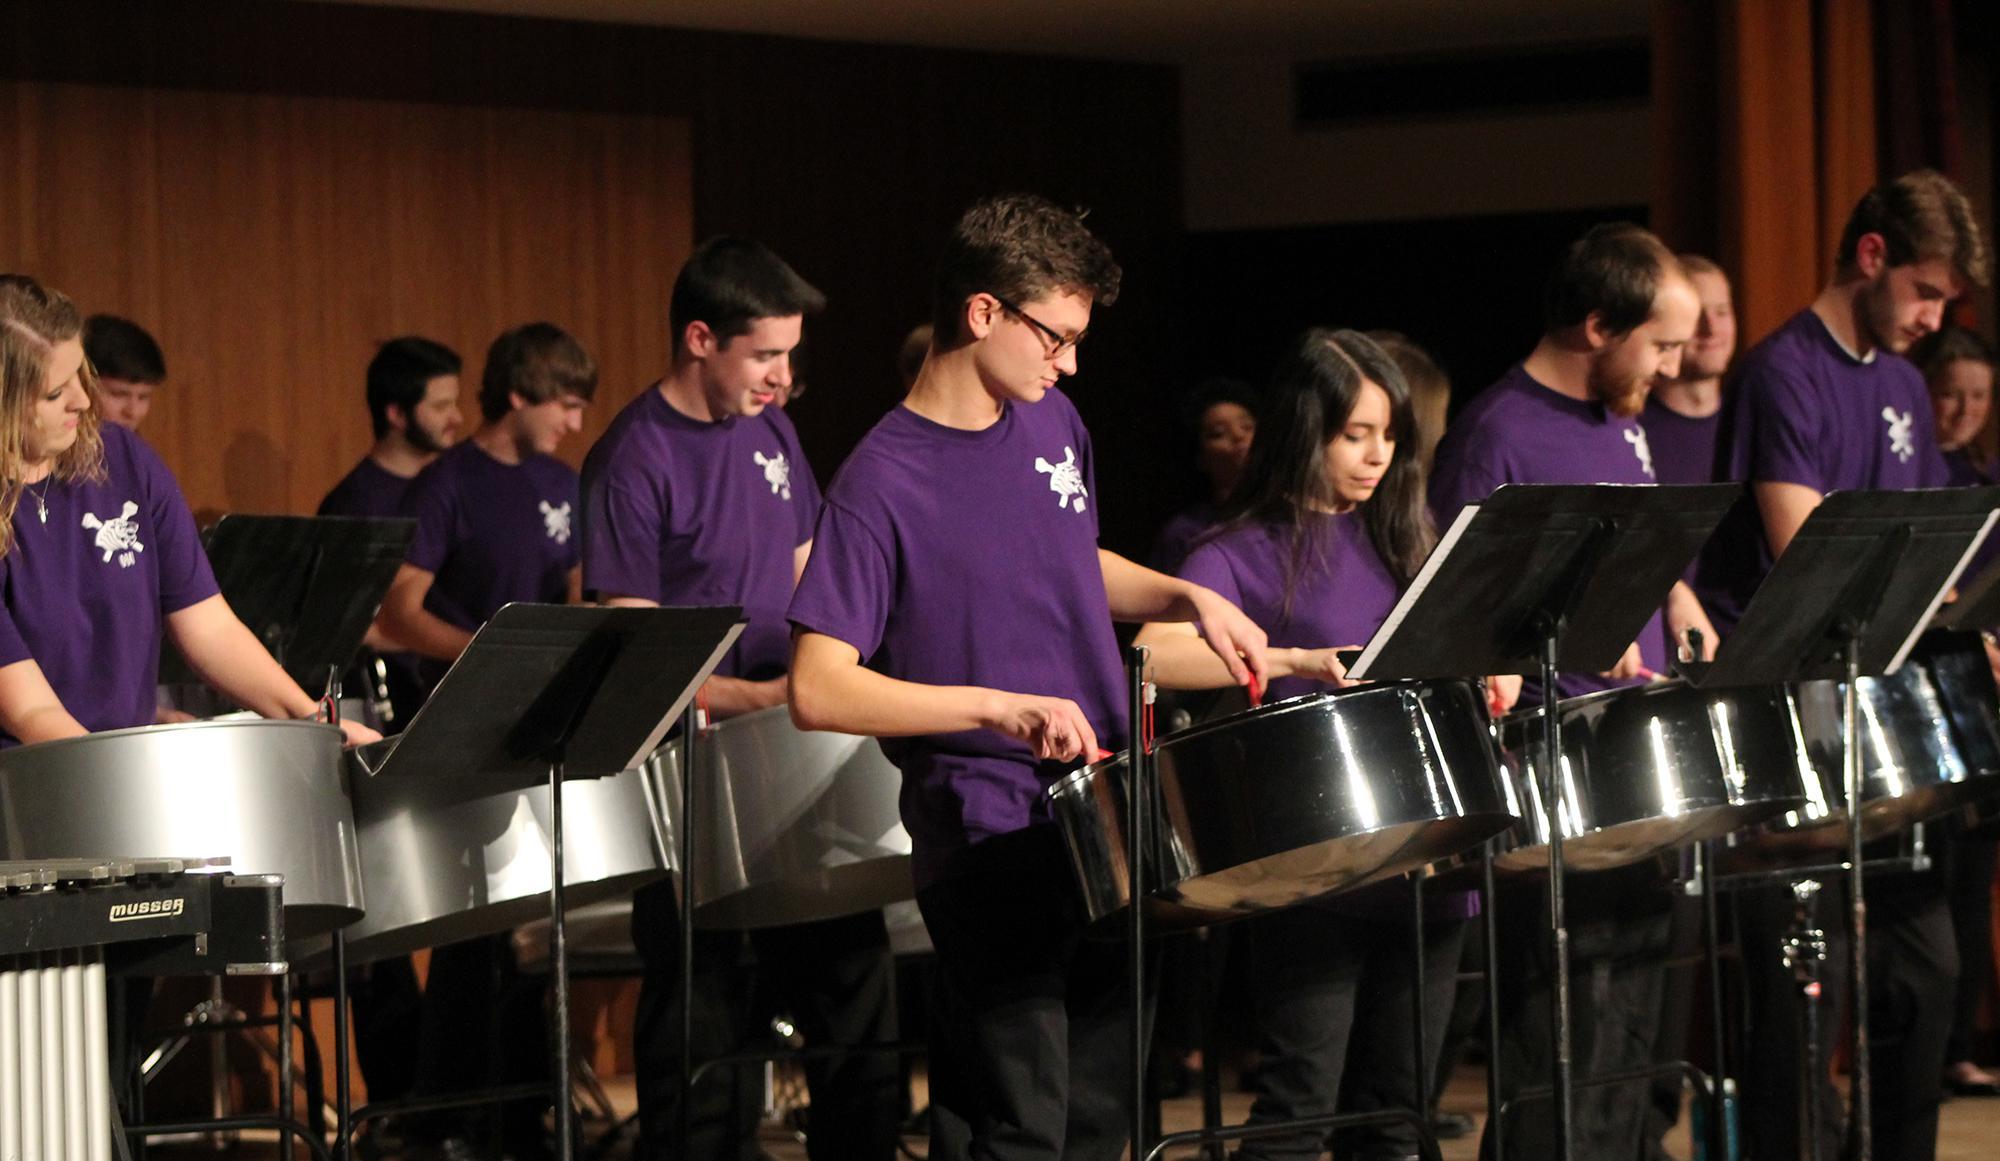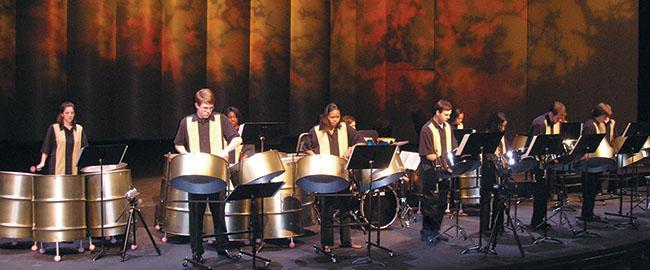The first image is the image on the left, the second image is the image on the right. For the images displayed, is the sentence "The left image shows a group of musicians in black pants and violet-blue short-sleeved shirts standing in front of cylindrical drums." factually correct? Answer yes or no. Yes. The first image is the image on the left, the second image is the image on the right. Given the left and right images, does the statement "All of the drummers in the image on the left are wearing purple shirts." hold true? Answer yes or no. Yes. 